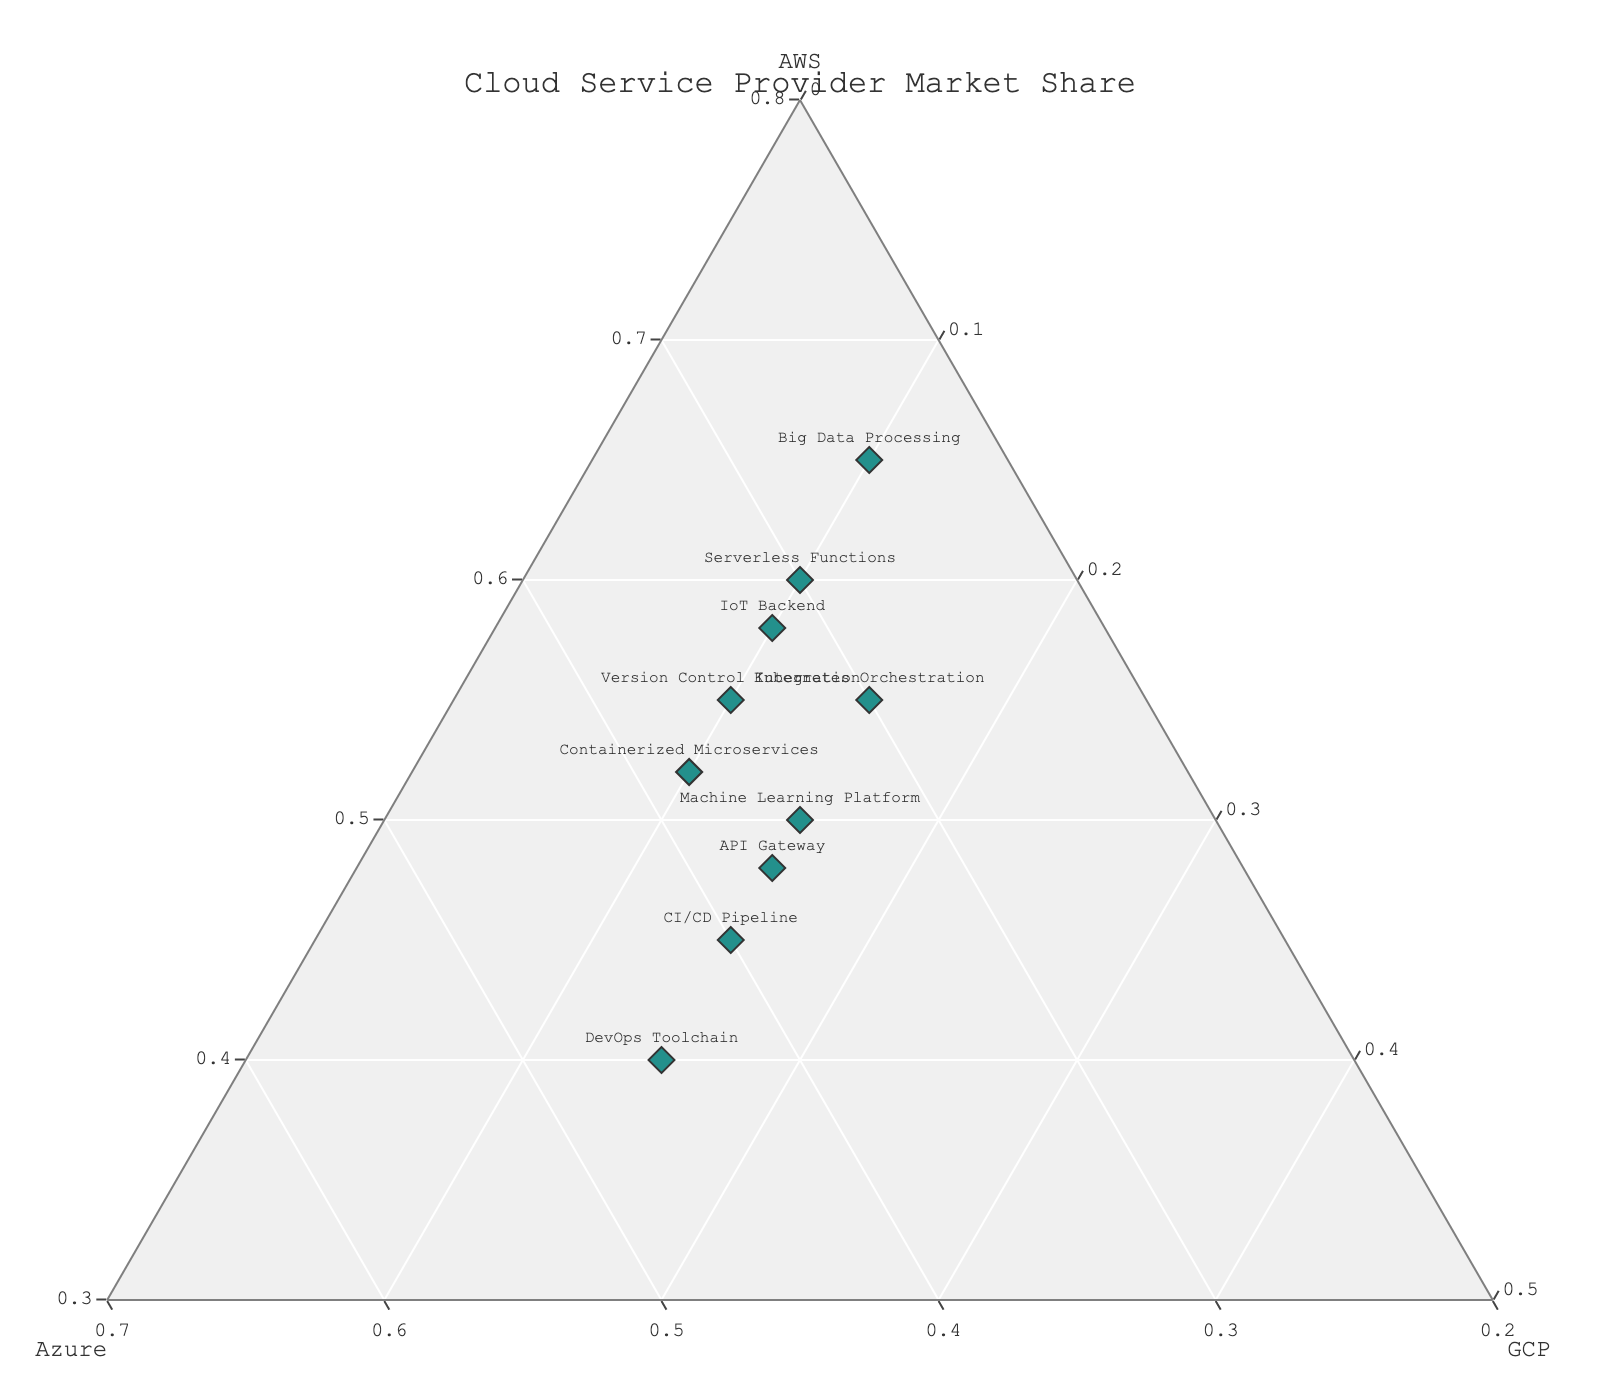What is the title of the ternary plot? The title of the plot is displayed at the top center of the figure. From the layout customization code, it is set as 'Cloud Service Provider Market Share' with font size 16.
Answer: Cloud Service Provider Market Share How many data points are shown in the plot? Each project represents a data point, and there are a total of 10 projects listed in the data. Therefore, there are 10 data points in the plot.
Answer: 10 Which project has the highest market share of AWS? Referring to the data provided, 'Big Data Processing' has the highest AWS market share at 65% compared to other projects.
Answer: Big Data Processing For the 'API Gateway' project, what percentage of market share does GCP have? The 'API Gateway' project has GCP market share data listed as 15. The normalized value on the plot is also computed during preparing the data for the plot.
Answer: 15% Which data point is closest to the center of the ternary plot? The center of the ternary plot represents an equal share among AWS, Azure, and GCP. The project closest to this center is 'CI/CD Pipeline', having a more balanced share among AWS (45%), Azure (40%), and GCP (15%).
Answer: CI/CD Pipeline Which projects share similar market patterns for AWS and Azure? By visual inspection, 'Containerized Microservices' and 'IoT Backend' projects both have relatively higher AWS shares around 52%-58% and Azure at 32%-38%, showing similar patterns.
Answer: Containerized Microservices, IoT Backend Can you identify the project with the smallest GCP market share? Based on the given data, all projects have at least 10% share in GCP, but they are tied. To distinguish, look at the data point plotted near the GCP apex, showing that both 'Big Data Processing' and several others too are exactly at 10%.
Answer: Big Data Processing (and others tied at 10%) Among 'DevOps Toolchain' and 'Machine Learning Platform', which one has a higher Azure market share? Observing the normalized values from the data, 'DevOps Toolchain' has an Azure share of 45% while 'Machine Learning Platform' has only 35%. Therefore, 'DevOps Toolchain' has a higher Azure market share.
Answer: DevOps Toolchain What is the average market share of GCP across all projects? Summing up the GCP shares from all projects: \(10 + 10 + 15 + 10 + 15 + 10 + 15 + 10 + 15 + 15 = 125\). Dividing by the number of projects (10), the average GCP share is \(125 / 10 = 12.5\).
Answer: 12.5% Which project has an AWS market share close to the overall mean of AWS values in the data? First, calculate the average AWS share: \( (52 + 60 + 45 + 55 + 40 + 65 + 50 + 58 + 48 + 55) / 10 = 52.8 \% \). Then, 'Containerized Microservices' reflects a very close data point with an AWS share of 52%.
Answer: Containerized Microservices 